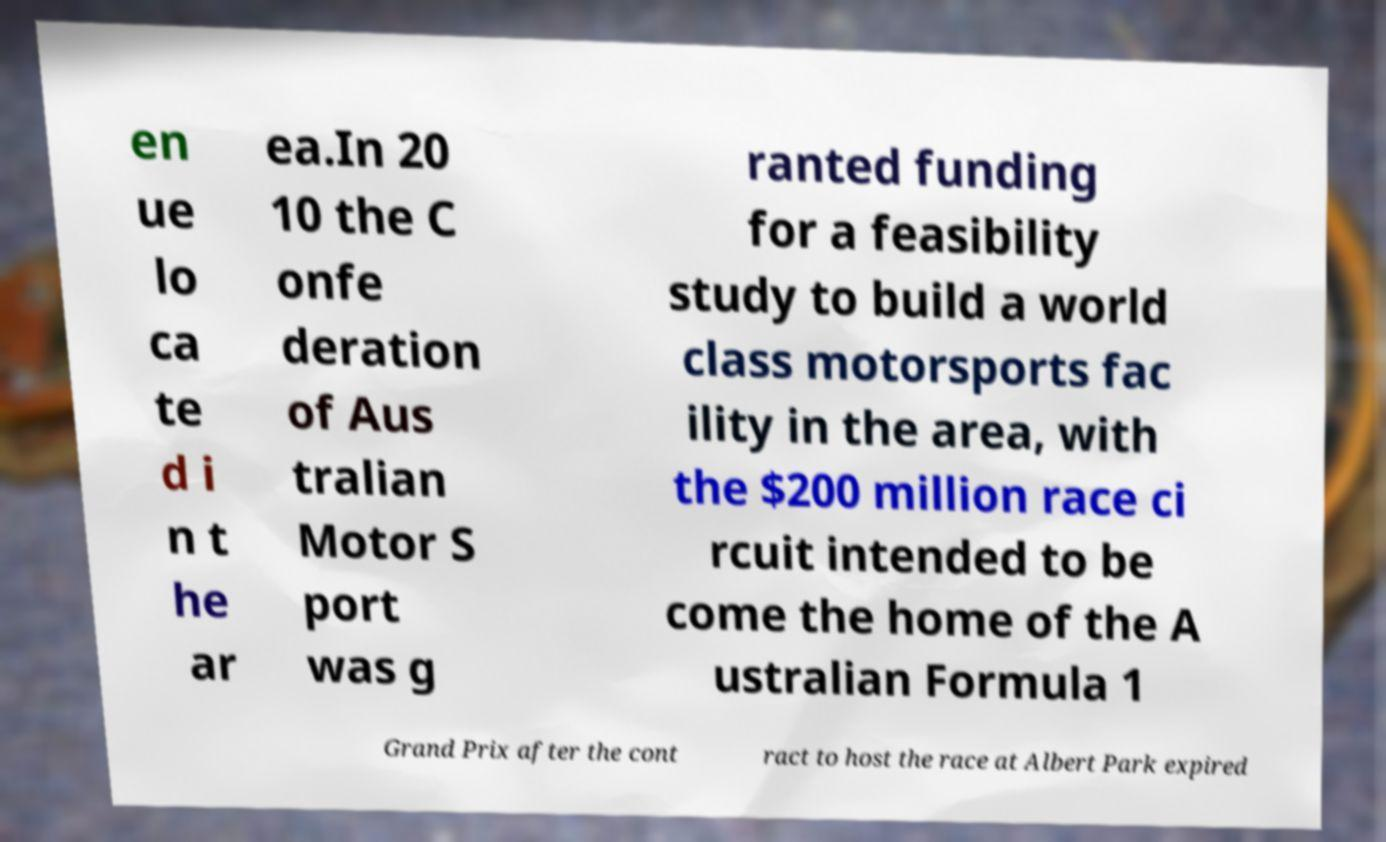Please identify and transcribe the text found in this image. en ue lo ca te d i n t he ar ea.In 20 10 the C onfe deration of Aus tralian Motor S port was g ranted funding for a feasibility study to build a world class motorsports fac ility in the area, with the $200 million race ci rcuit intended to be come the home of the A ustralian Formula 1 Grand Prix after the cont ract to host the race at Albert Park expired 